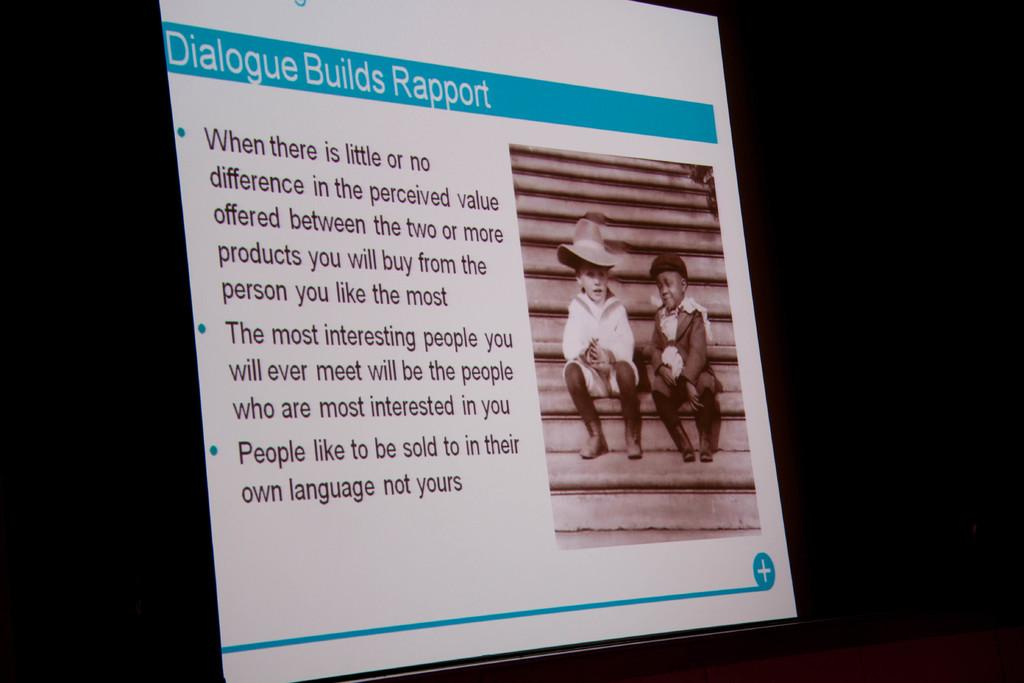How many children are present in the image? There are two kids in the image. What are the kids doing in the image? The kids are sitting on the steps. What type of butter is being used by the kids in the image? There is no butter present in the image; the kids are simply sitting on the steps. 